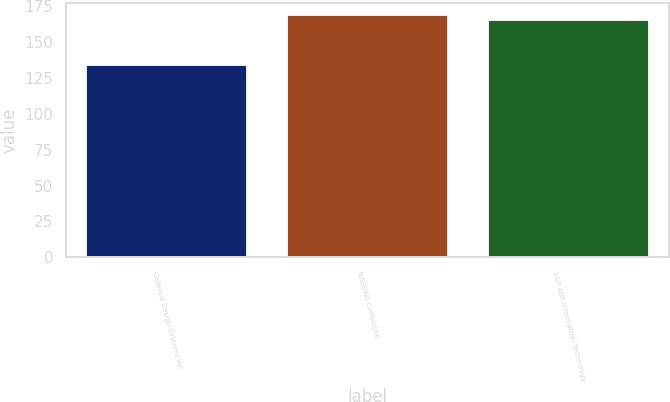<chart> <loc_0><loc_0><loc_500><loc_500><bar_chart><fcel>Cadence Design Systems Inc<fcel>NASDAQ Composite<fcel>S&P 400 Information Technology<nl><fcel>133.94<fcel>168.53<fcel>165.38<nl></chart> 